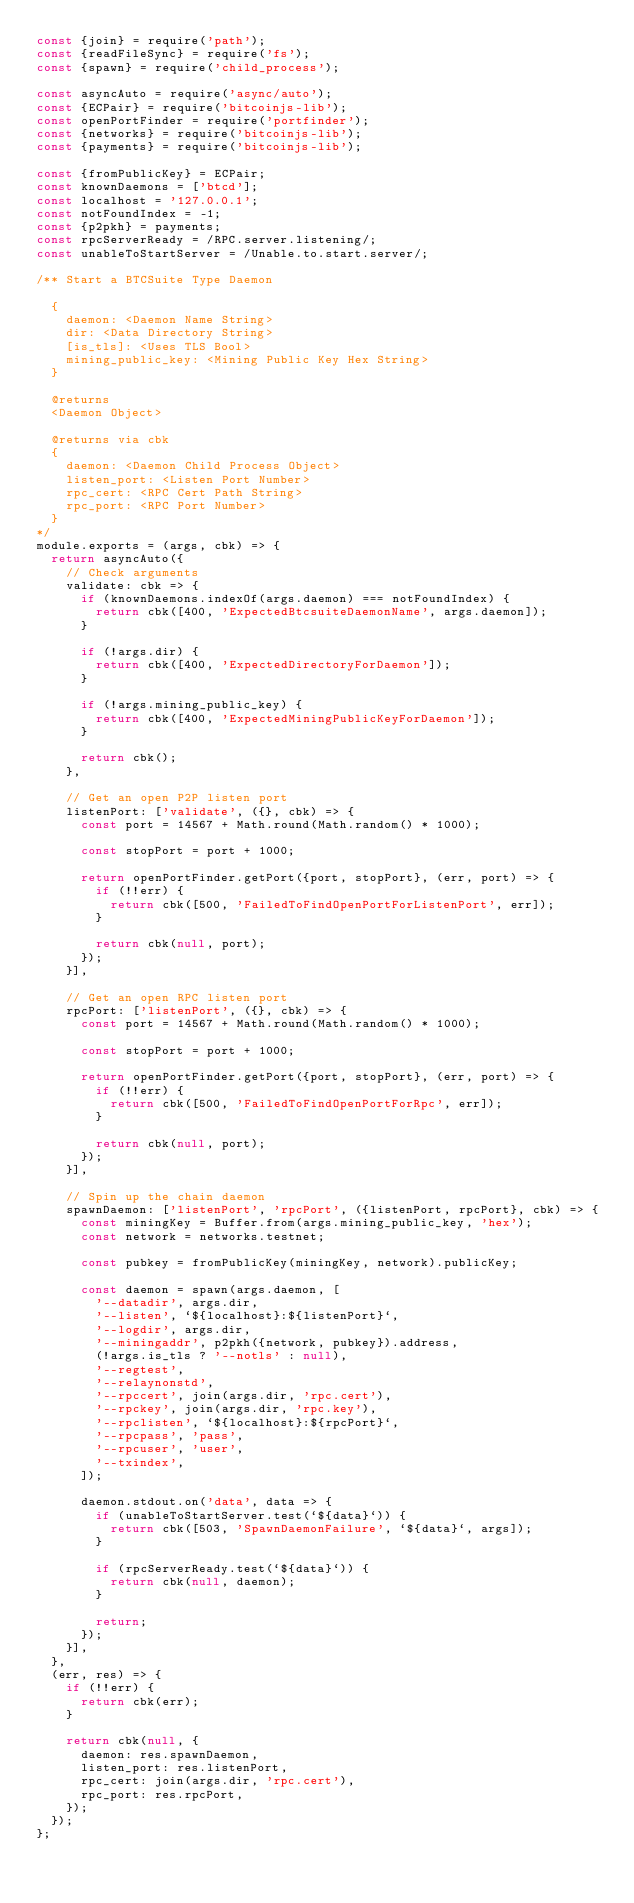Convert code to text. <code><loc_0><loc_0><loc_500><loc_500><_JavaScript_>const {join} = require('path');
const {readFileSync} = require('fs');
const {spawn} = require('child_process');

const asyncAuto = require('async/auto');
const {ECPair} = require('bitcoinjs-lib');
const openPortFinder = require('portfinder');
const {networks} = require('bitcoinjs-lib');
const {payments} = require('bitcoinjs-lib');

const {fromPublicKey} = ECPair;
const knownDaemons = ['btcd'];
const localhost = '127.0.0.1';
const notFoundIndex = -1;
const {p2pkh} = payments;
const rpcServerReady = /RPC.server.listening/;
const unableToStartServer = /Unable.to.start.server/;

/** Start a BTCSuite Type Daemon

  {
    daemon: <Daemon Name String>
    dir: <Data Directory String>
    [is_tls]: <Uses TLS Bool>
    mining_public_key: <Mining Public Key Hex String>
  }

  @returns
  <Daemon Object>

  @returns via cbk
  {
    daemon: <Daemon Child Process Object>
    listen_port: <Listen Port Number>
    rpc_cert: <RPC Cert Path String>
    rpc_port: <RPC Port Number>
  }
*/
module.exports = (args, cbk) => {
  return asyncAuto({
    // Check arguments
    validate: cbk => {
      if (knownDaemons.indexOf(args.daemon) === notFoundIndex) {
        return cbk([400, 'ExpectedBtcsuiteDaemonName', args.daemon]);
      }

      if (!args.dir) {
        return cbk([400, 'ExpectedDirectoryForDaemon']);
      }

      if (!args.mining_public_key) {
        return cbk([400, 'ExpectedMiningPublicKeyForDaemon']);
      }

      return cbk();
    },

    // Get an open P2P listen port
    listenPort: ['validate', ({}, cbk) => {
      const port = 14567 + Math.round(Math.random() * 1000);

      const stopPort = port + 1000;

      return openPortFinder.getPort({port, stopPort}, (err, port) => {
        if (!!err) {
          return cbk([500, 'FailedToFindOpenPortForListenPort', err]);
        }

        return cbk(null, port);
      });
    }],

    // Get an open RPC listen port
    rpcPort: ['listenPort', ({}, cbk) => {
      const port = 14567 + Math.round(Math.random() * 1000);

      const stopPort = port + 1000;

      return openPortFinder.getPort({port, stopPort}, (err, port) => {
        if (!!err) {
          return cbk([500, 'FailedToFindOpenPortForRpc', err]);
        }

        return cbk(null, port);
      });
    }],

    // Spin up the chain daemon
    spawnDaemon: ['listenPort', 'rpcPort', ({listenPort, rpcPort}, cbk) => {
      const miningKey = Buffer.from(args.mining_public_key, 'hex');
      const network = networks.testnet;

      const pubkey = fromPublicKey(miningKey, network).publicKey;

      const daemon = spawn(args.daemon, [
        '--datadir', args.dir,
        '--listen', `${localhost}:${listenPort}`,
        '--logdir', args.dir,
        '--miningaddr', p2pkh({network, pubkey}).address,
        (!args.is_tls ? '--notls' : null),
        '--regtest',
        '--relaynonstd',
        '--rpccert', join(args.dir, 'rpc.cert'),
        '--rpckey', join(args.dir, 'rpc.key'),
        '--rpclisten', `${localhost}:${rpcPort}`,
        '--rpcpass', 'pass',
        '--rpcuser', 'user',
        '--txindex',
      ]);

      daemon.stdout.on('data', data => {
        if (unableToStartServer.test(`${data}`)) {
          return cbk([503, 'SpawnDaemonFailure', `${data}`, args]);
        }

        if (rpcServerReady.test(`${data}`)) {
          return cbk(null, daemon);
        }

        return;
      });
    }],
  },
  (err, res) => {
    if (!!err) {
      return cbk(err);
    }

    return cbk(null, {
      daemon: res.spawnDaemon,
      listen_port: res.listenPort,
      rpc_cert: join(args.dir, 'rpc.cert'),
      rpc_port: res.rpcPort,
    });
  });
};
</code> 